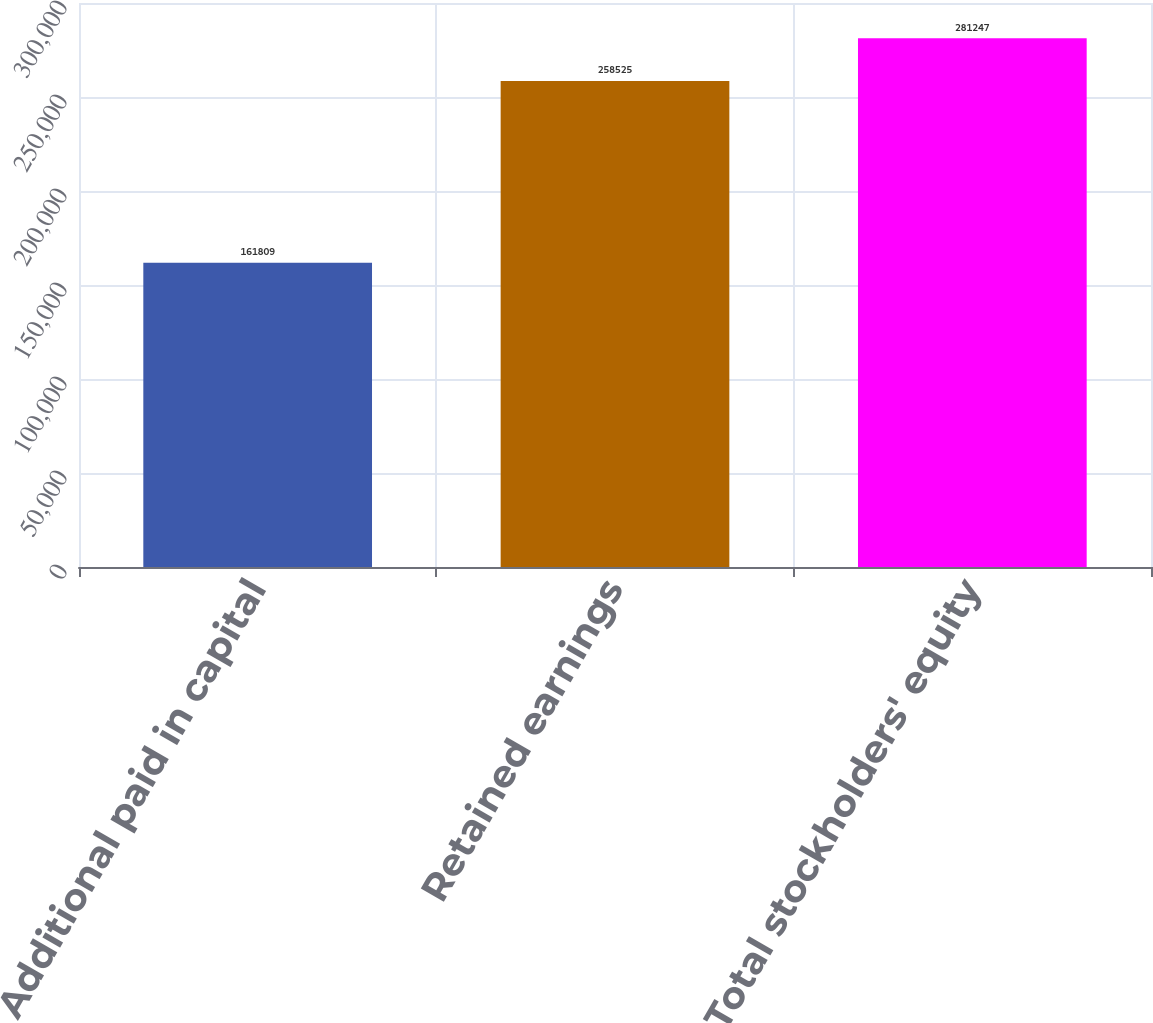<chart> <loc_0><loc_0><loc_500><loc_500><bar_chart><fcel>Additional paid in capital<fcel>Retained earnings<fcel>Total stockholders' equity<nl><fcel>161809<fcel>258525<fcel>281247<nl></chart> 